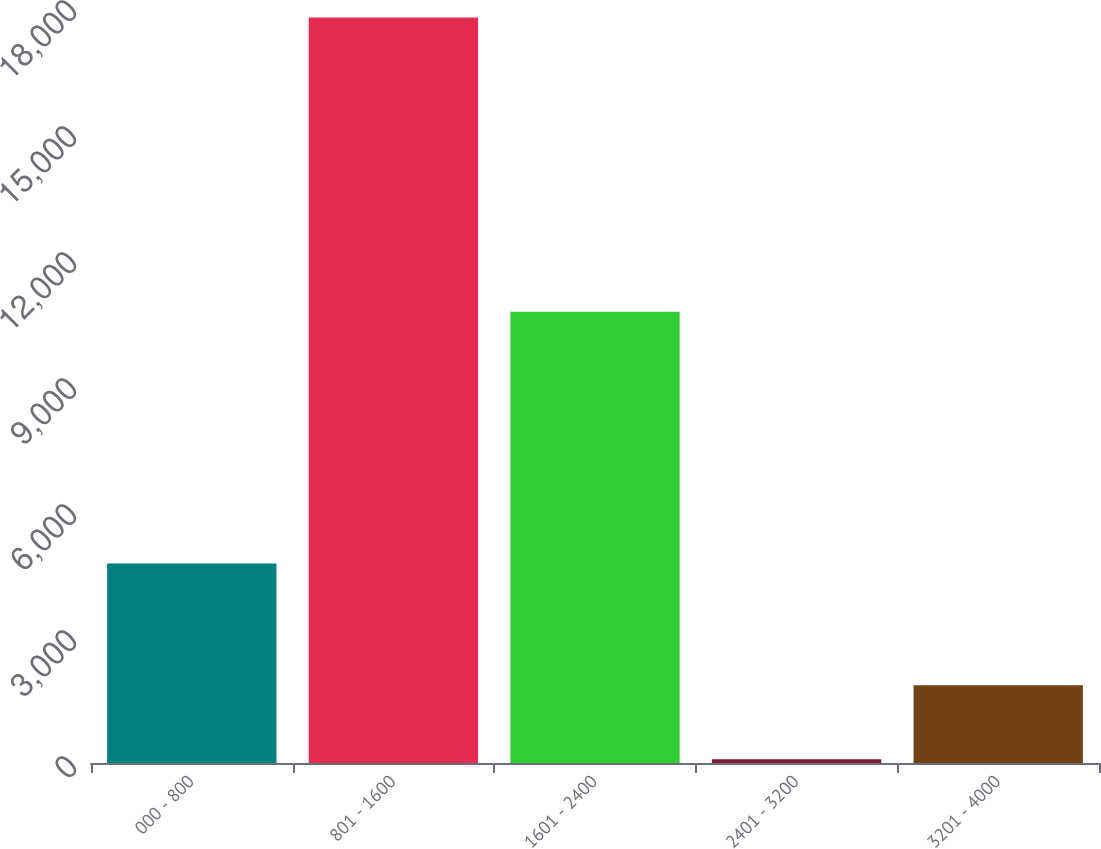Convert chart. <chart><loc_0><loc_0><loc_500><loc_500><bar_chart><fcel>000 - 800<fcel>801 - 1600<fcel>1601 - 2400<fcel>2401 - 3200<fcel>3201 - 4000<nl><fcel>4750<fcel>17749<fcel>10742<fcel>88<fcel>1854.1<nl></chart> 